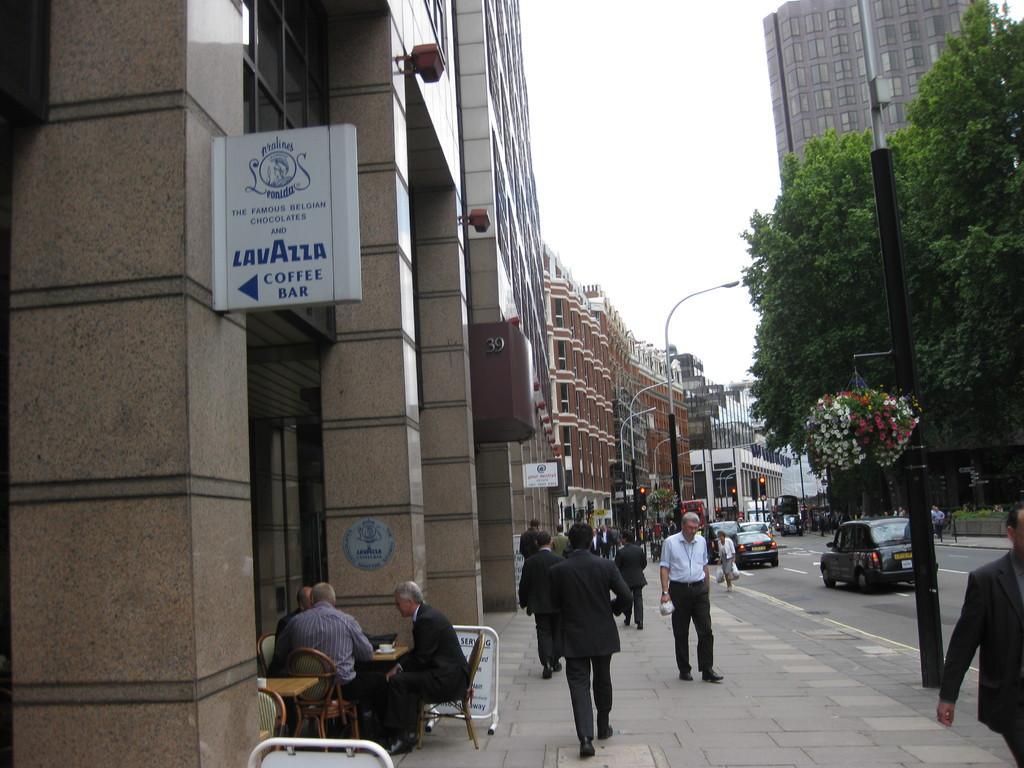How would you summarize this image in a sentence or two? In this image we can see some people walking on the footpath. We can also see some cars on the road. On the left side we can see some buildings with windows and a board. We can also see three people sitting on the chairs beside a table containing a cup on it. On the right side we can see a plant with flowers hanged to a pole. On the backside we can see traffic lights, street poles, trees and the sky which looks cloudy. 